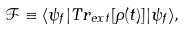<formula> <loc_0><loc_0><loc_500><loc_500>\mathcal { F } \equiv \langle \psi _ { f } | T r _ { e x t } [ \rho ( t ) ] | \psi _ { f } \rangle ,</formula> 